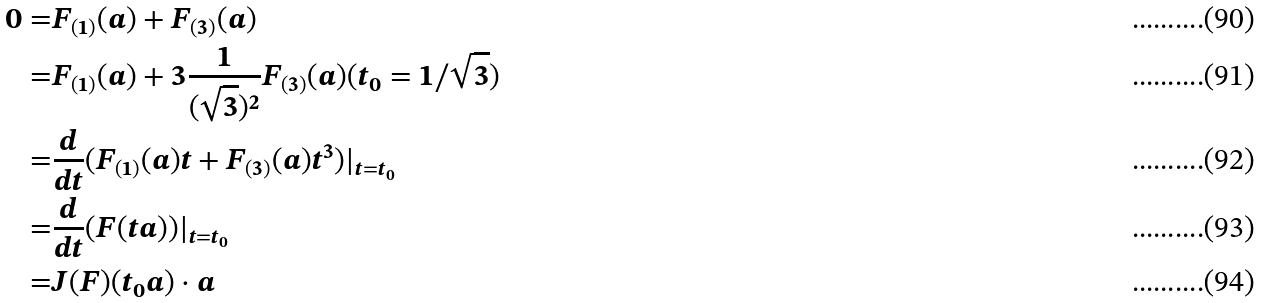Convert formula to latex. <formula><loc_0><loc_0><loc_500><loc_500>0 = & F _ { ( 1 ) } ( a ) + F _ { ( 3 ) } ( a ) \\ = & F _ { ( 1 ) } ( a ) + 3 \frac { 1 } { ( \sqrt { 3 } ) ^ { 2 } } F _ { ( 3 ) } ( a ) ( t _ { 0 } = 1 / \sqrt { 3 } ) \\ = & \frac { d } { d t } ( F _ { ( 1 ) } ( a ) t + F _ { ( 3 ) } ( a ) t ^ { 3 } ) | _ { t = t _ { 0 } } \\ = & \frac { d } { d t } ( F ( t a ) ) | _ { t = t _ { 0 } } \\ = & J ( F ) ( t _ { 0 } a ) \cdot a</formula> 